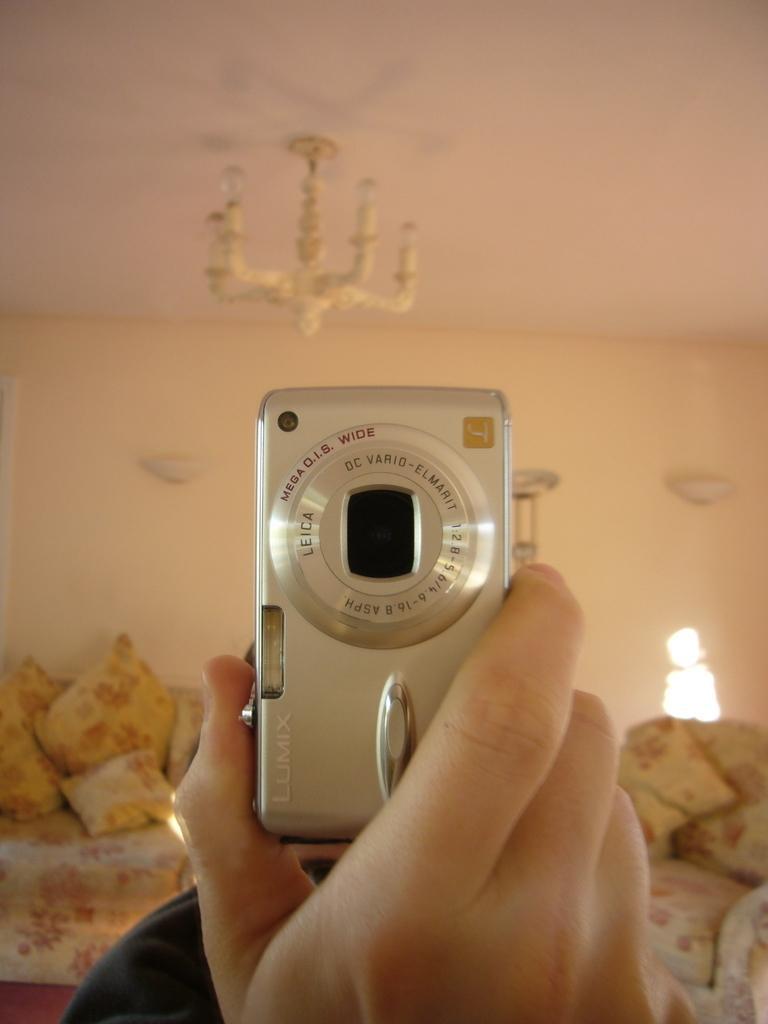Please provide a concise description of this image. In this picture I can see a hand of a person holding a camera, there are pillows, there is a chair, couch, chandelier, and in the background there is a wall. 